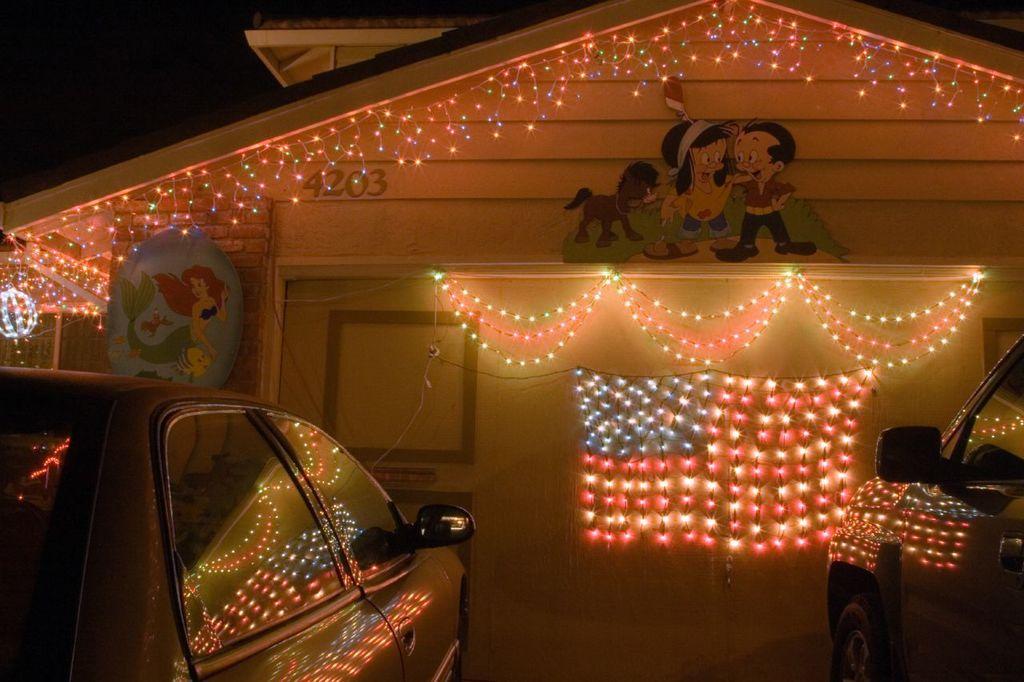Can you describe this image briefly? This is an image clicked in the dark. On the right and left sides of the image I can see two cars. At the back there is a house decorated with the lights and few cartoon boards are attached to the walls. 